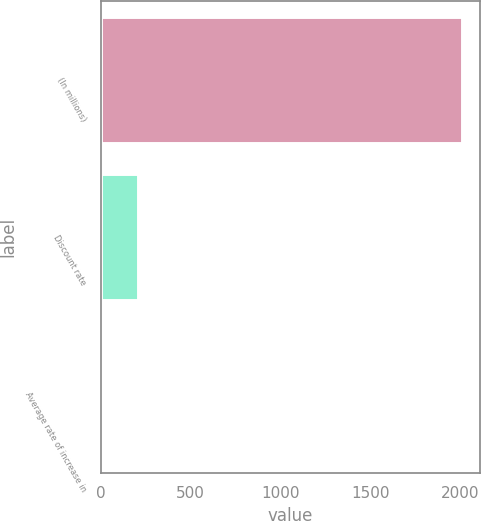<chart> <loc_0><loc_0><loc_500><loc_500><bar_chart><fcel>(In millions)<fcel>Discount rate<fcel>Average rate of increase in<nl><fcel>2011<fcel>204.7<fcel>4<nl></chart> 